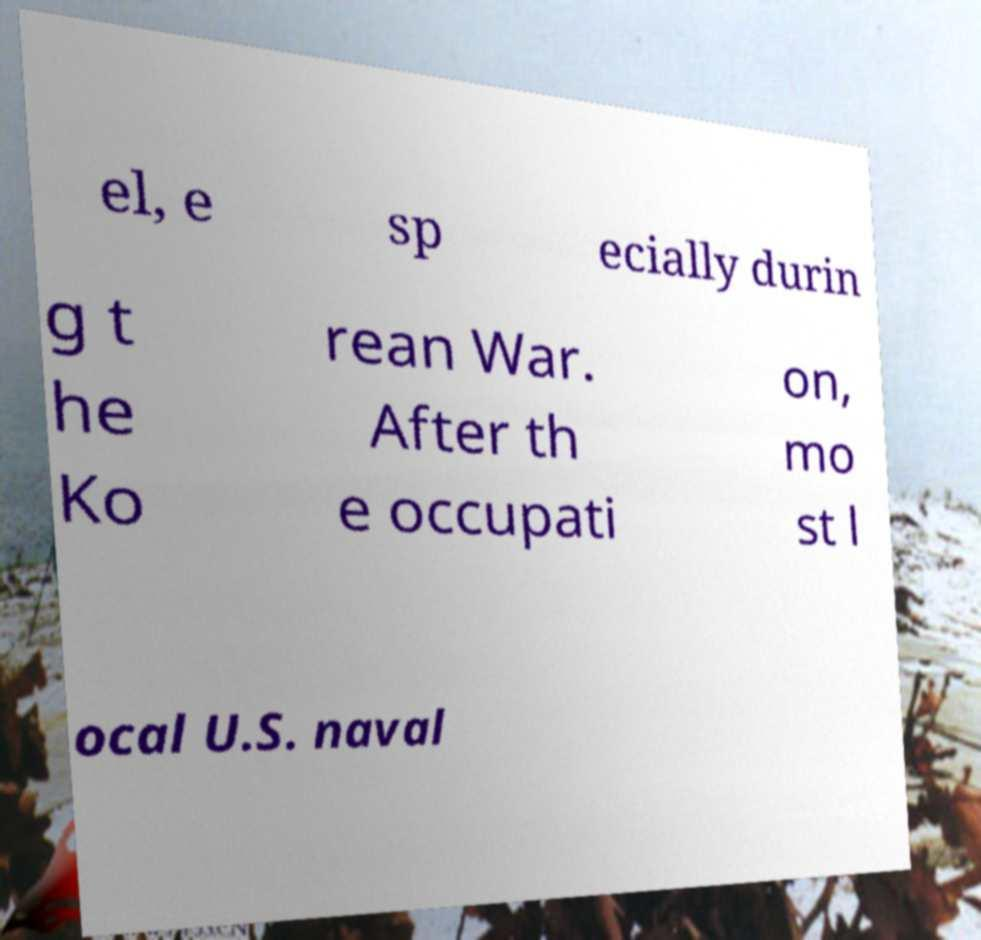Could you assist in decoding the text presented in this image and type it out clearly? el, e sp ecially durin g t he Ko rean War. After th e occupati on, mo st l ocal U.S. naval 